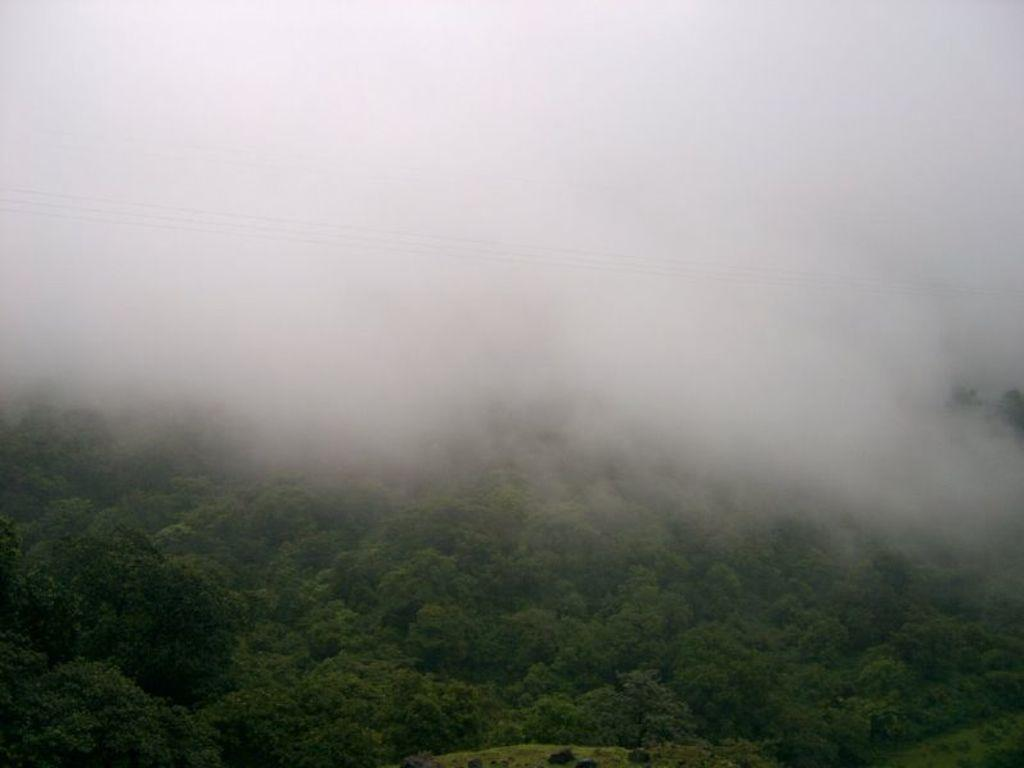What color are the trees in the image? The trees in the image are green. Can you describe the top part of the image? The top part of the image appears to be foggy. What type of water can be seen burning in the image? There is no water or burning element present in the image. 